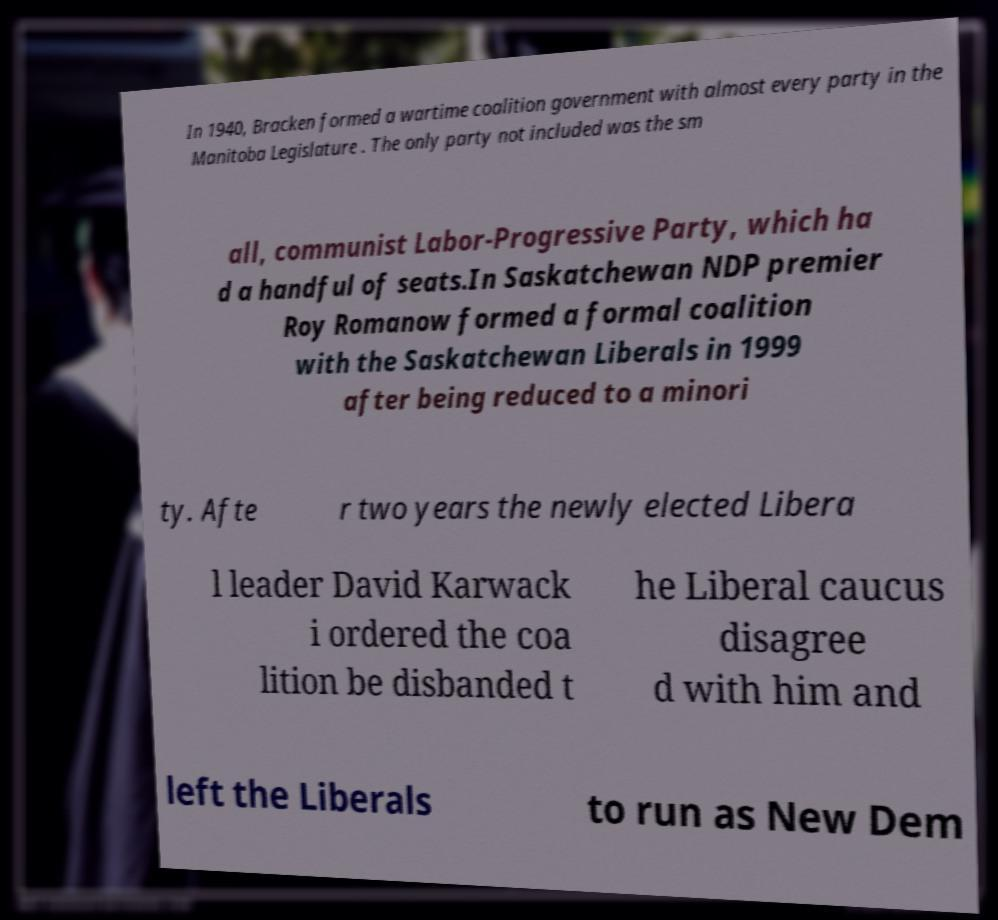Can you accurately transcribe the text from the provided image for me? In 1940, Bracken formed a wartime coalition government with almost every party in the Manitoba Legislature . The only party not included was the sm all, communist Labor-Progressive Party, which ha d a handful of seats.In Saskatchewan NDP premier Roy Romanow formed a formal coalition with the Saskatchewan Liberals in 1999 after being reduced to a minori ty. Afte r two years the newly elected Libera l leader David Karwack i ordered the coa lition be disbanded t he Liberal caucus disagree d with him and left the Liberals to run as New Dem 